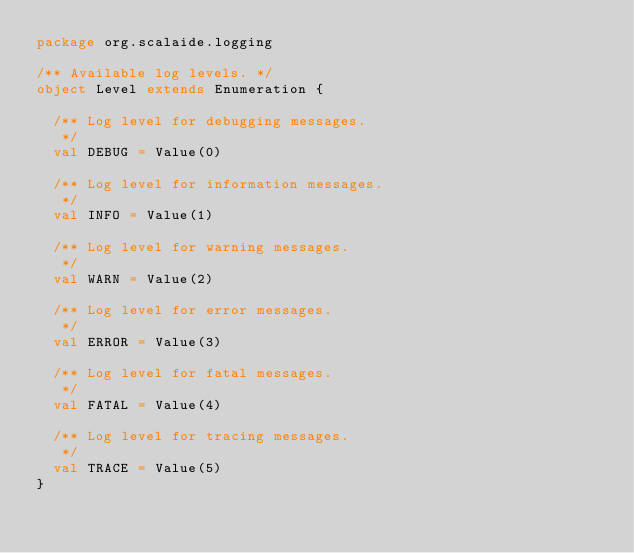Convert code to text. <code><loc_0><loc_0><loc_500><loc_500><_Scala_>package org.scalaide.logging

/** Available log levels. */
object Level extends Enumeration {

  /** Log level for debugging messages.
   */
  val DEBUG = Value(0)

  /** Log level for information messages.
   */
  val INFO = Value(1)

  /** Log level for warning messages.
   */
  val WARN = Value(2)

  /** Log level for error messages.
   */
  val ERROR = Value(3)

  /** Log level for fatal messages.
   */
  val FATAL = Value(4)

  /** Log level for tracing messages.
   */
  val TRACE = Value(5)
}
</code> 